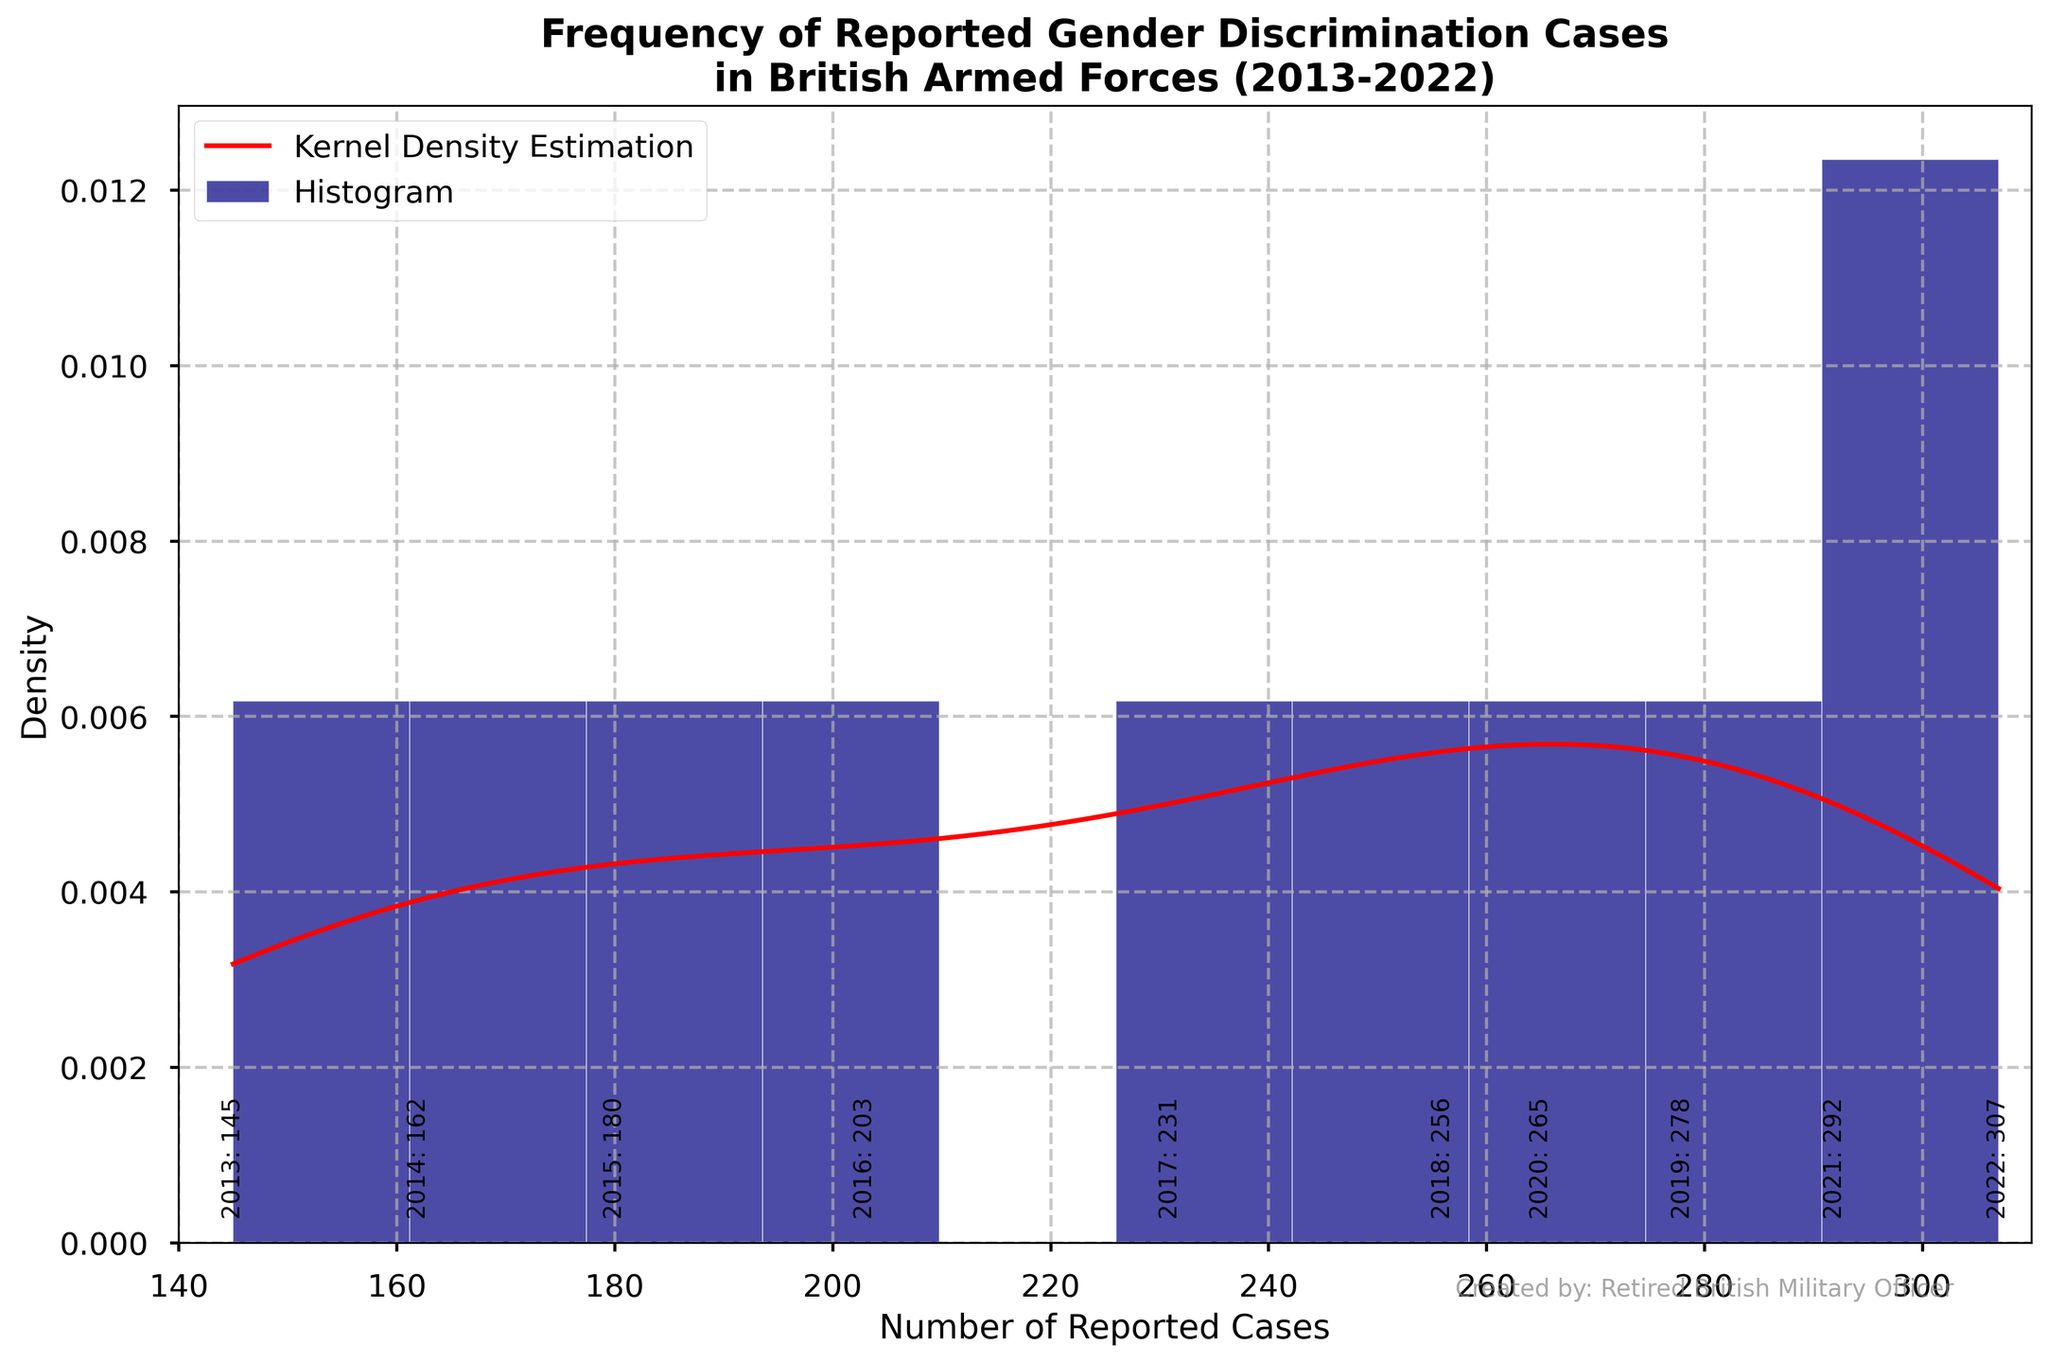What is the title of the figure? The title of the figure is displayed at the top. It states "Frequency of Reported Gender Discrimination Cases in British Armed Forces (2013-2022)."
Answer: Frequency of Reported Gender Discrimination Cases in British Armed Forces (2013-2022) What are the labels of the x and y axes? The x-axis label is "Number of Reported Cases" and the y-axis label is "Density." These labels are found under the horizontal axis and along the vertical axis, respectively.
Answer: Number of Reported Cases, Density How many data points (years) are annotated in the histogram? There are 10 years listed, from 2013 to 2022, each annotated along the histogram. This can be counted directly from the figure.
Answer: 10 Which year had the highest number of reported cases and what was the number? The year with the highest count is annotated in the histogram. It is 2022 with 307 reported cases.
Answer: 2022, 307 Which year saw the lowest number of reported cases and how many cases were there? The year with the lowest count can be found by looking for the lowest annotation in the histogram, which is 2013 with 145 reported cases.
Answer: 2013, 145 What is the range of reported cases in the figure? The range of reported cases is from the lowest value in the histogram to the highest. The lowest is 145 (2013) and the highest is 307 (2022). Therefore, the range is 307 - 145.
Answer: 162 What does the red line represent in the figure? The red line represents the Kernel Density Estimation (KDE), a smoothed continuous probability density curve that estimates the density of the reported cases data.
Answer: KDE Is the distribution of reported cases skewed, and if so, in which direction? By observing the KDE curve, the distribution appears skewed left, meaning more data points are clustered towards the higher values.
Answer: Left-skewed How does the highest density region of the KDE relate to the histogram bars? The highest density region of the KDE corresponds to where most of the histogram bars are concentrated. This region appears to be around the higher end of the reported cases (near 260-300).
Answer: 260-300 Compare the number of reported cases between 2015 and 2020. Which year experienced more cases and by how much? Look at the annotations for 2015 and 2020. 2015 had 180 cases, and 2020 had 265 cases. Subtract 180 from 265 to find the difference.
Answer: 2020, 85 What trend do you observe in the number of reported cases over the decade? The annotations indicate that the number of reported cases shows an increasing trend from 2013 to 2022. This can be seen as the annotations list higher numbers each successive year.
Answer: Increasing trend 